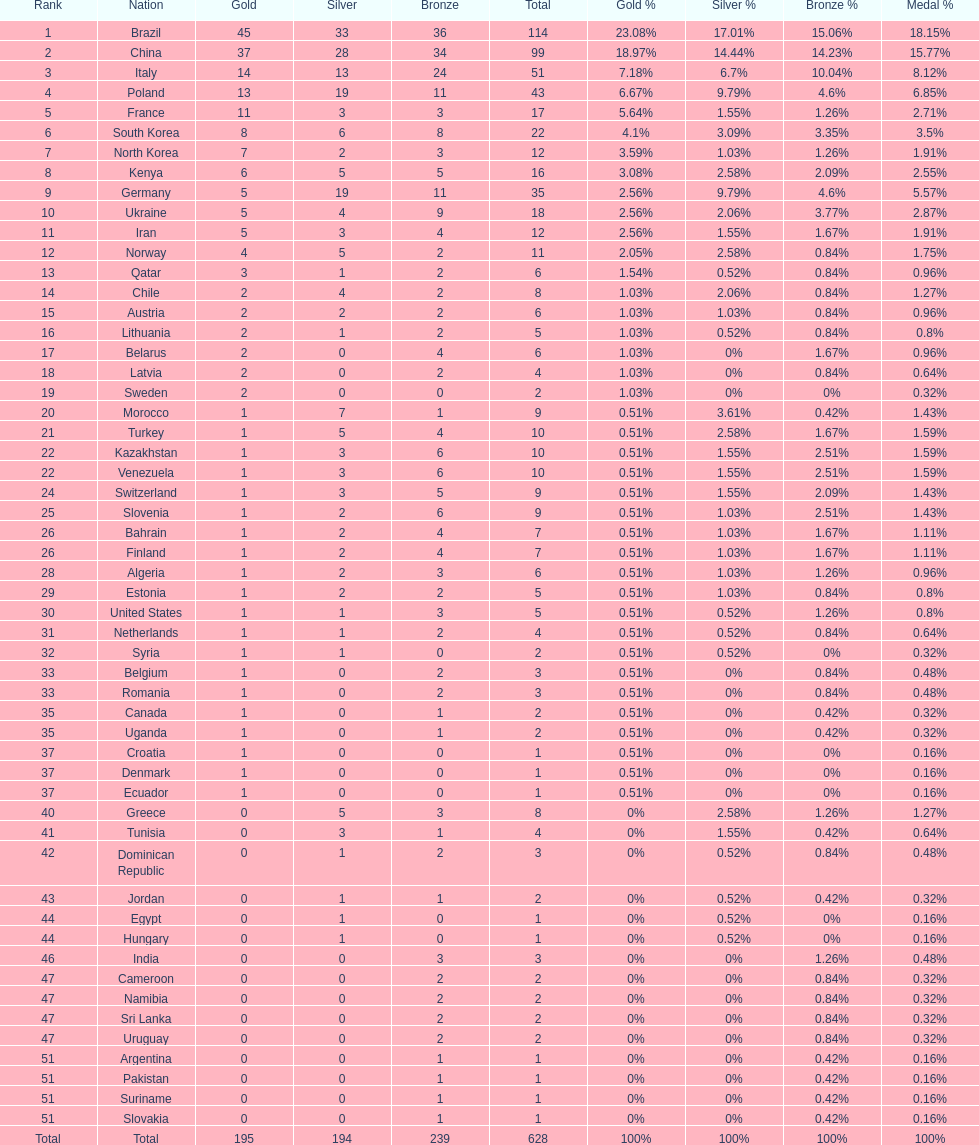Who only won 13 silver medals? Italy. 